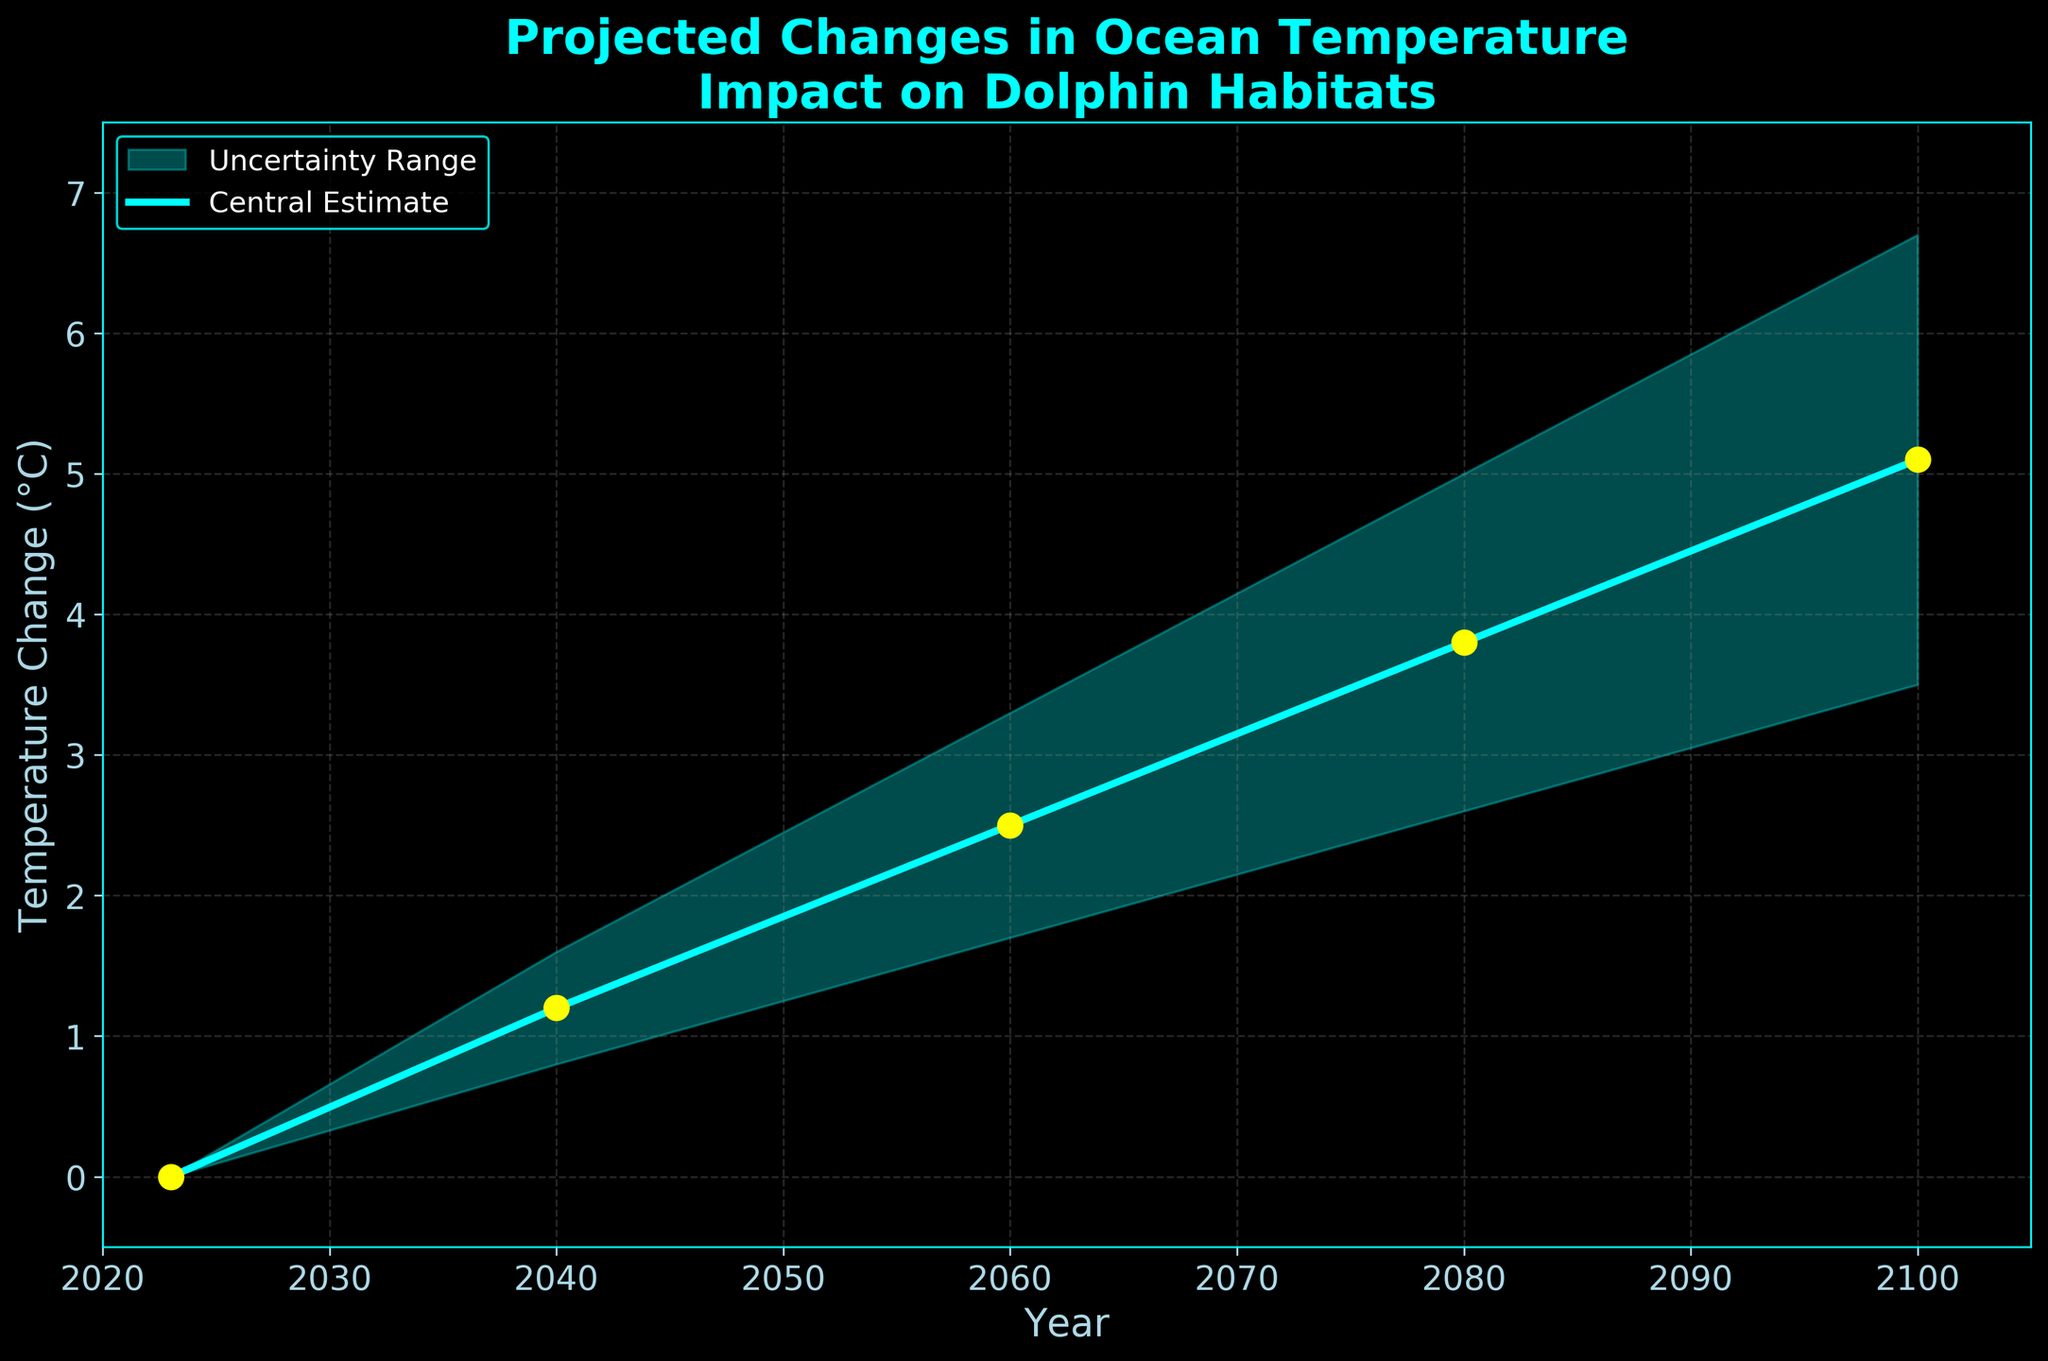What is the title of the figure? The title is prominently displayed at the top of the figure.
Answer: Projected Changes in Ocean Temperature Impact on Dolphin Habitats How does the ocean temperature change from 2023 to 2100 according to the Central Estimate? By tracing the Central Estimate line from 2023 to 2100, we see it increases from 0°C to 5.1°C.
Answer: 5.1°C increase What is the range of temperature change predicted for the year 2060? Observe the bounds at 2060; the Lower Bound is 1.7°C and the Upper Bound is 3.3°C, giving a range from 1.7°C to 3.3°C.
Answer: 1.7°C to 3.3°C In which year do we see the largest increase in the Central Estimate compared to the previous year? Calculating differences between consecutive years: 2040-2023 (+1.2), 2060-2040 (+1.3), 2080-2060 (+1.3), and 2100-2080 (+1.3). The largest increase overall is +1.3°C. Thus, from 2060 to 2080, 2080 to 2100, or 2040 to 2060.
Answer: 2060, 2080, 2100 How does the uncertainty range change from 2040 to 2100? Compare the uncertainty range (Upper Bound - Lower Bound) at 2040 (1.6 - 0.8 = 0.8°C) and at 2100 (6.7 - 3.5 = 3.2°C). Uncertainty increases from 0.8°C to 3.2°C.
Answer: Increases What is the color used to represent the Central Estimate line? The Central Estimate line is clearly marked in the legend and is colored cyan.
Answer: Cyan How many data points are there in the figure? Count the years listed along the x-axis or the scatter points on the Central Estimate line. There are 5 years: 2023, 2040, 2060, 2080, and 2100.
Answer: 5 data points What is the temperature increase from 2040 to 2080 according to the Central Estimate? Subtract the Central Estimate at 2040 (1.2°C) from the Central Estimate at 2080 (3.8°C). 3.8°C - 1.2°C = 2.6°C.
Answer: 2.6°C Which year has the smallest uncertainty range? By comparing the uncertainty ranges (Upper Bound - Lower Bound) across all years: 2023 (0°C), 2040 (0.8°C), 2060 (1.6°C), 2080 (2.4°C), 2100 (3.2°C). The smallest range is at 2023.
Answer: 2023 At what temperature change do we reach the Upper Bound in the year 2100? Observing the Upper Bound line for 2100, the value is shown as 6.7°C.
Answer: 6.7°C 